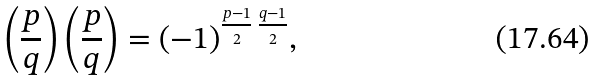Convert formula to latex. <formula><loc_0><loc_0><loc_500><loc_500>\left ( \frac { p } { q } \right ) \left ( \frac { p } { q } \right ) = ( - 1 ) ^ { \frac { p - 1 } { 2 } \, \frac { q - 1 } { 2 } } ,</formula> 